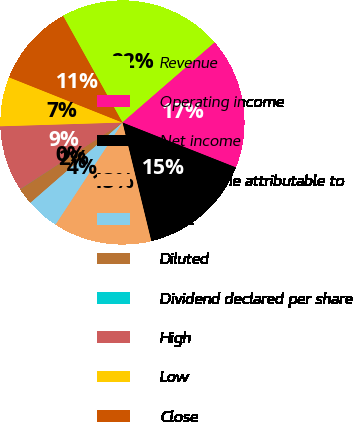Convert chart. <chart><loc_0><loc_0><loc_500><loc_500><pie_chart><fcel>Revenue<fcel>Operating income<fcel>Net income<fcel>Net income attributable to<fcel>Basic<fcel>Diluted<fcel>Dividend declared per share<fcel>High<fcel>Low<fcel>Close<nl><fcel>21.72%<fcel>17.38%<fcel>15.21%<fcel>13.04%<fcel>4.36%<fcel>2.19%<fcel>0.02%<fcel>8.7%<fcel>6.53%<fcel>10.87%<nl></chart> 